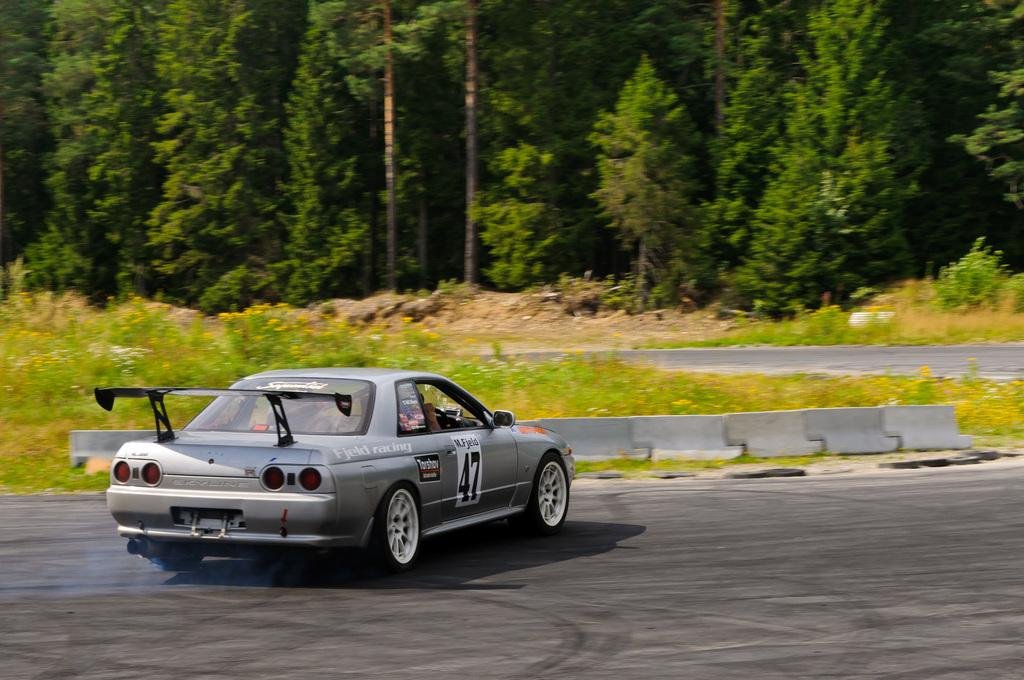What is the main subject of the image? The main subject of the image is a car. What is the car doing in the image? The car is moving on the road in the image. What type of vegetation can be seen in the image? There are plants, grass, and trees visible in the image. What type of music is being played by the dog in the image? There is no dog or music present in the image. 